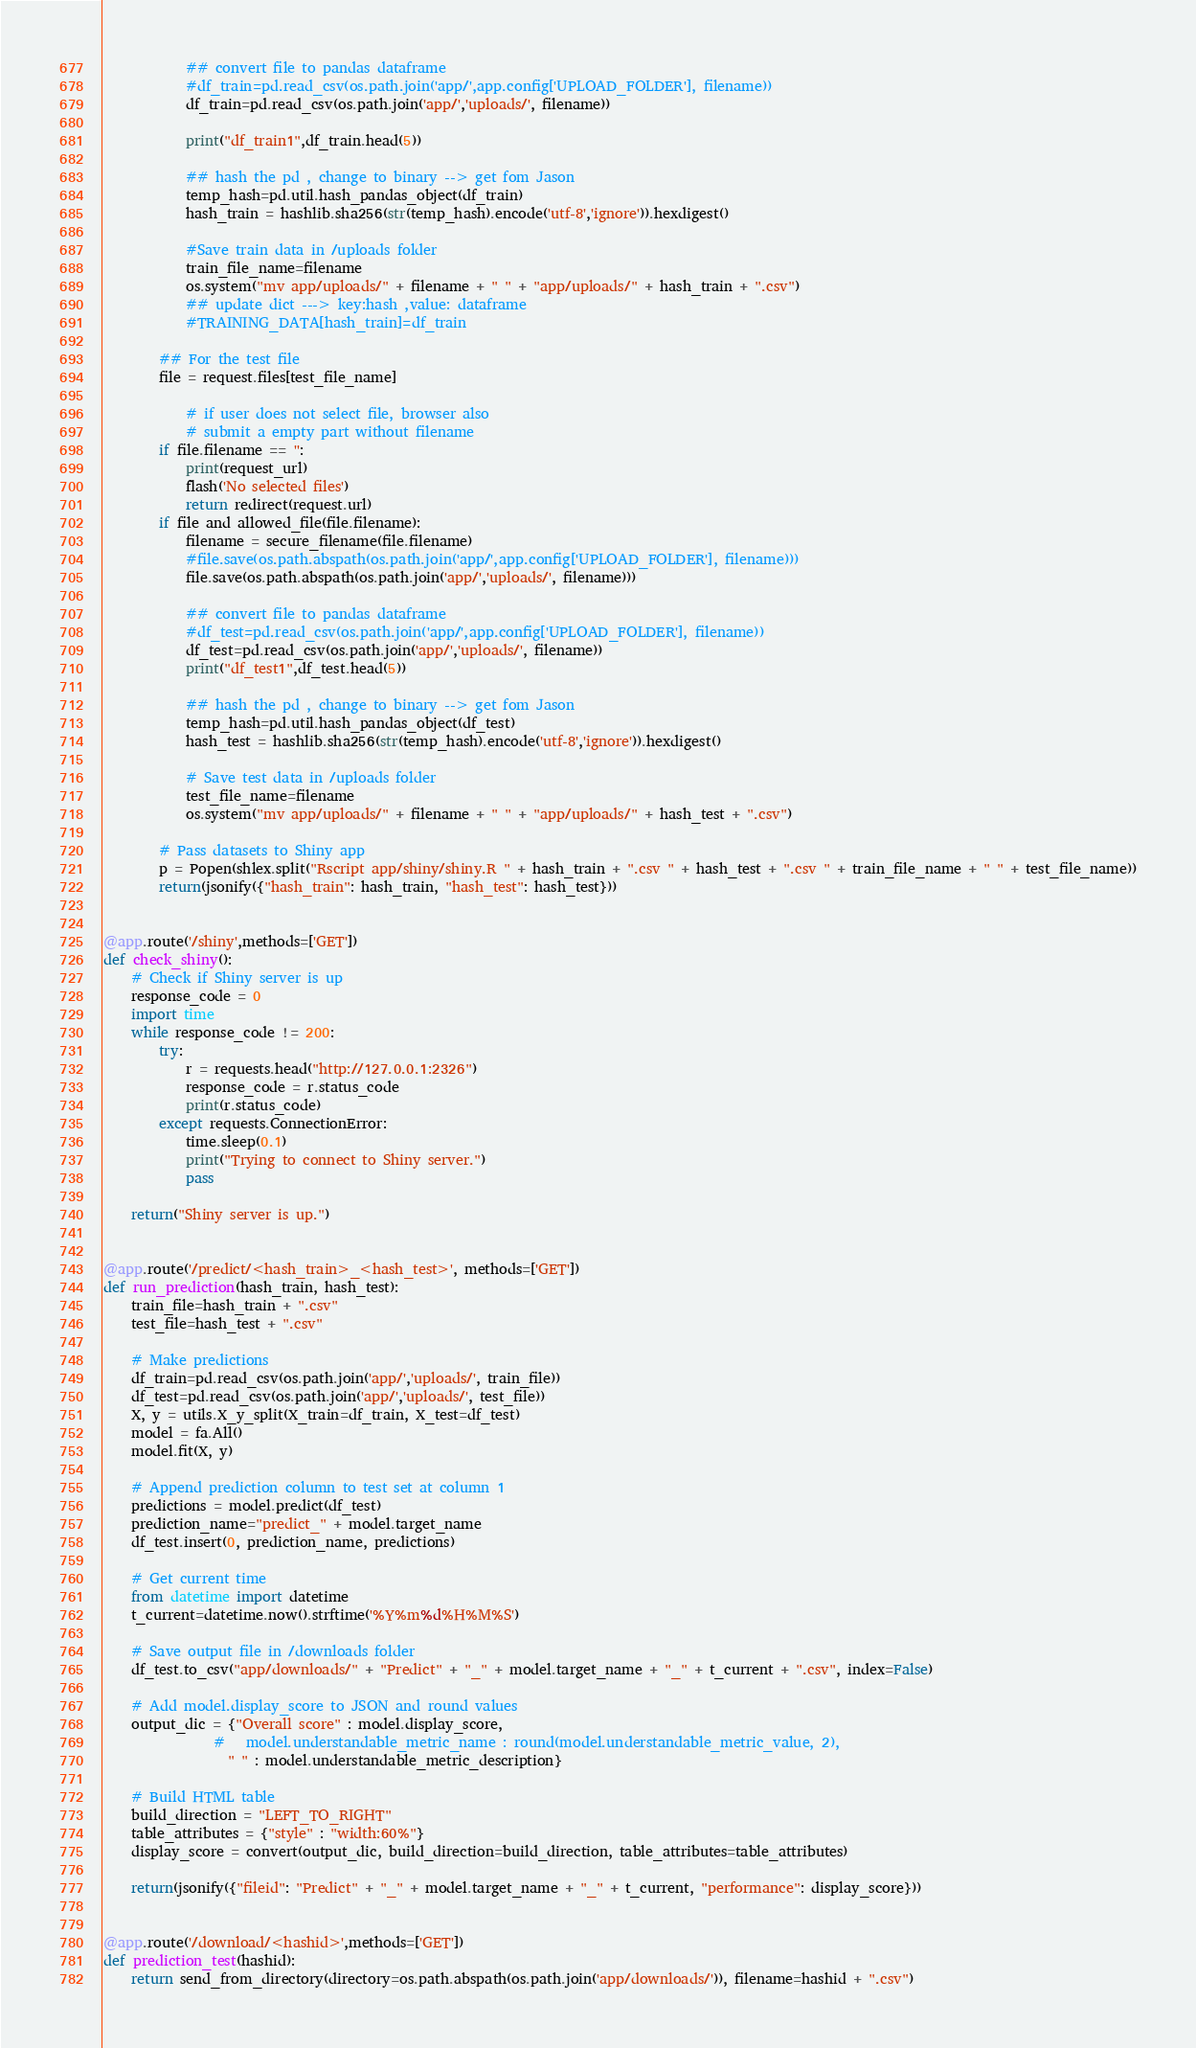Convert code to text. <code><loc_0><loc_0><loc_500><loc_500><_Python_>			## convert file to pandas dataframe
			#df_train=pd.read_csv(os.path.join('app/',app.config['UPLOAD_FOLDER'], filename))
			df_train=pd.read_csv(os.path.join('app/','uploads/', filename))

			print("df_train1",df_train.head(5))

			## hash the pd , change to binary --> get fom Jason
			temp_hash=pd.util.hash_pandas_object(df_train)
			hash_train = hashlib.sha256(str(temp_hash).encode('utf-8','ignore')).hexdigest()

			#Save train data in /uploads folder
			train_file_name=filename
			os.system("mv app/uploads/" + filename + " " + "app/uploads/" + hash_train + ".csv")
			## update dict ---> key:hash ,value: dataframe
			#TRAINING_DATA[hash_train]=df_train

		## For the test file
		file = request.files[test_file_name]

			# if user does not select file, browser also
			# submit a empty part without filename
		if file.filename == '':
			print(request_url)
			flash('No selected files')
			return redirect(request.url)
		if file and allowed_file(file.filename):
			filename = secure_filename(file.filename)
			#file.save(os.path.abspath(os.path.join('app/',app.config['UPLOAD_FOLDER'], filename)))
			file.save(os.path.abspath(os.path.join('app/','uploads/', filename)))

			## convert file to pandas dataframe
			#df_test=pd.read_csv(os.path.join('app/',app.config['UPLOAD_FOLDER'], filename))
			df_test=pd.read_csv(os.path.join('app/','uploads/', filename))
			print("df_test1",df_test.head(5))

			## hash the pd , change to binary --> get fom Jason
			temp_hash=pd.util.hash_pandas_object(df_test)
			hash_test = hashlib.sha256(str(temp_hash).encode('utf-8','ignore')).hexdigest()

			# Save test data in /uploads folder
			test_file_name=filename
			os.system("mv app/uploads/" + filename + " " + "app/uploads/" + hash_test + ".csv")

		# Pass datasets to Shiny app
		p = Popen(shlex.split("Rscript app/shiny/shiny.R " + hash_train + ".csv " + hash_test + ".csv " + train_file_name + " " + test_file_name))
		return(jsonify({"hash_train": hash_train, "hash_test": hash_test}))


@app.route('/shiny',methods=['GET'])
def check_shiny():
	# Check if Shiny server is up
	response_code = 0
	import time
	while response_code != 200:
		try:
			r = requests.head("http://127.0.0.1:2326")
			response_code = r.status_code
			print(r.status_code)
		except requests.ConnectionError:
			time.sleep(0.1)
			print("Trying to connect to Shiny server.")
			pass

	return("Shiny server is up.")


@app.route('/predict/<hash_train>_<hash_test>', methods=['GET'])
def run_prediction(hash_train, hash_test):
	train_file=hash_train + ".csv"
	test_file=hash_test + ".csv"

	# Make predictions
	df_train=pd.read_csv(os.path.join('app/','uploads/', train_file))
	df_test=pd.read_csv(os.path.join('app/','uploads/', test_file))
	X, y = utils.X_y_split(X_train=df_train, X_test=df_test)
	model = fa.All()
	model.fit(X, y)

	# Append prediction column to test set at column 1
	predictions = model.predict(df_test)
	prediction_name="predict_" + model.target_name
	df_test.insert(0, prediction_name, predictions)

	# Get current time
	from datetime import datetime
	t_current=datetime.now().strftime('%Y%m%d%H%M%S')

	# Save output file in /downloads folder
	df_test.to_csv("app/downloads/" + "Predict" + "_" + model.target_name + "_" + t_current + ".csv", index=False)

	# Add model.display_score to JSON and round values
	output_dic = {"Overall score" : model.display_score,
				#   model.understandable_metric_name : round(model.understandable_metric_value, 2),
				  " " : model.understandable_metric_description}

	# Build HTML table
	build_direction = "LEFT_TO_RIGHT"
	table_attributes = {"style" : "width:60%"}
	display_score = convert(output_dic, build_direction=build_direction, table_attributes=table_attributes)

	return(jsonify({"fileid": "Predict" + "_" + model.target_name + "_" + t_current, "performance": display_score}))


@app.route('/download/<hashid>',methods=['GET'])
def prediction_test(hashid):
	return send_from_directory(directory=os.path.abspath(os.path.join('app/downloads/')), filename=hashid + ".csv")
</code> 